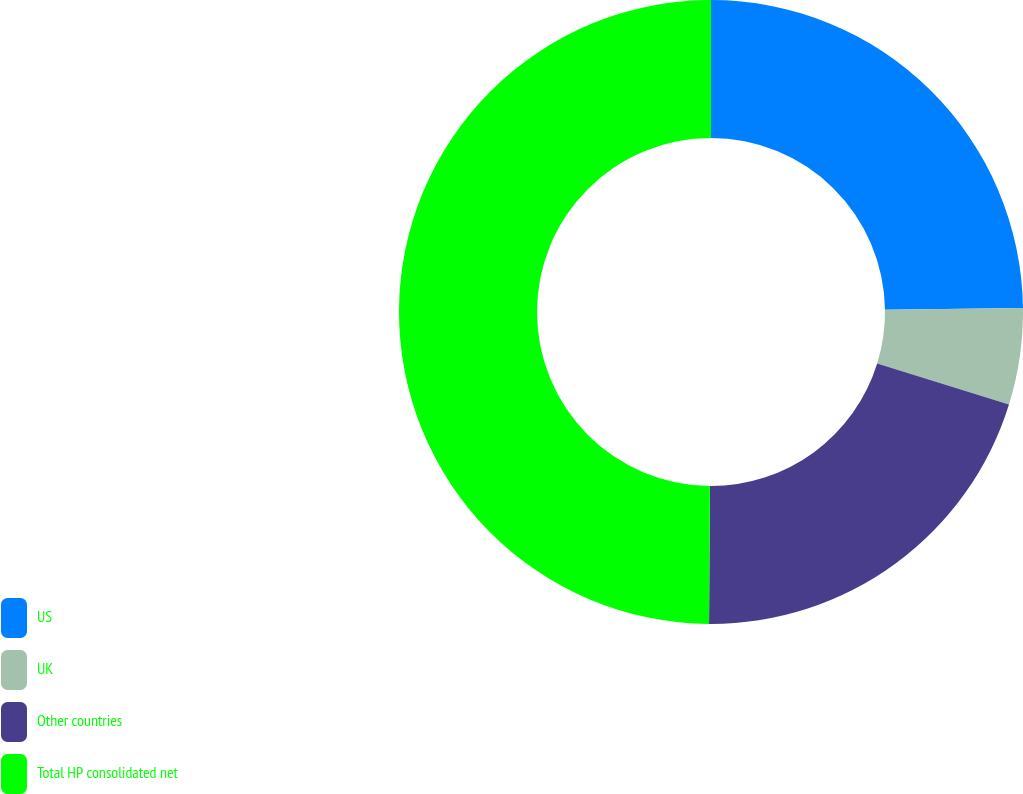Convert chart. <chart><loc_0><loc_0><loc_500><loc_500><pie_chart><fcel>US<fcel>UK<fcel>Other countries<fcel>Total HP consolidated net<nl><fcel>24.8%<fcel>4.99%<fcel>20.31%<fcel>49.9%<nl></chart> 